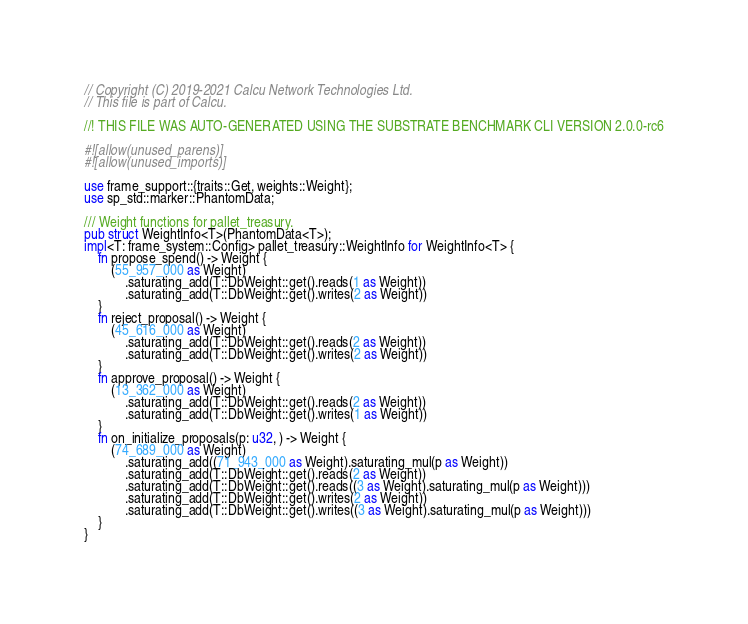<code> <loc_0><loc_0><loc_500><loc_500><_Rust_>// Copyright (C) 2019-2021 Calcu Network Technologies Ltd.
// This file is part of Calcu.

//! THIS FILE WAS AUTO-GENERATED USING THE SUBSTRATE BENCHMARK CLI VERSION 2.0.0-rc6

#![allow(unused_parens)]
#![allow(unused_imports)]

use frame_support::{traits::Get, weights::Weight};
use sp_std::marker::PhantomData;

/// Weight functions for pallet_treasury.
pub struct WeightInfo<T>(PhantomData<T>);
impl<T: frame_system::Config> pallet_treasury::WeightInfo for WeightInfo<T> {
	fn propose_spend() -> Weight {
		(55_957_000 as Weight)
			.saturating_add(T::DbWeight::get().reads(1 as Weight))
			.saturating_add(T::DbWeight::get().writes(2 as Weight))
	}
	fn reject_proposal() -> Weight {
		(45_616_000 as Weight)
			.saturating_add(T::DbWeight::get().reads(2 as Weight))
			.saturating_add(T::DbWeight::get().writes(2 as Weight))
	}
	fn approve_proposal() -> Weight {
		(13_362_000 as Weight)
			.saturating_add(T::DbWeight::get().reads(2 as Weight))
			.saturating_add(T::DbWeight::get().writes(1 as Weight))
	}
	fn on_initialize_proposals(p: u32, ) -> Weight {
		(74_689_000 as Weight)
			.saturating_add((71_943_000 as Weight).saturating_mul(p as Weight))
			.saturating_add(T::DbWeight::get().reads(2 as Weight))
			.saturating_add(T::DbWeight::get().reads((3 as Weight).saturating_mul(p as Weight)))
			.saturating_add(T::DbWeight::get().writes(2 as Weight))
			.saturating_add(T::DbWeight::get().writes((3 as Weight).saturating_mul(p as Weight)))
	}
}
</code> 